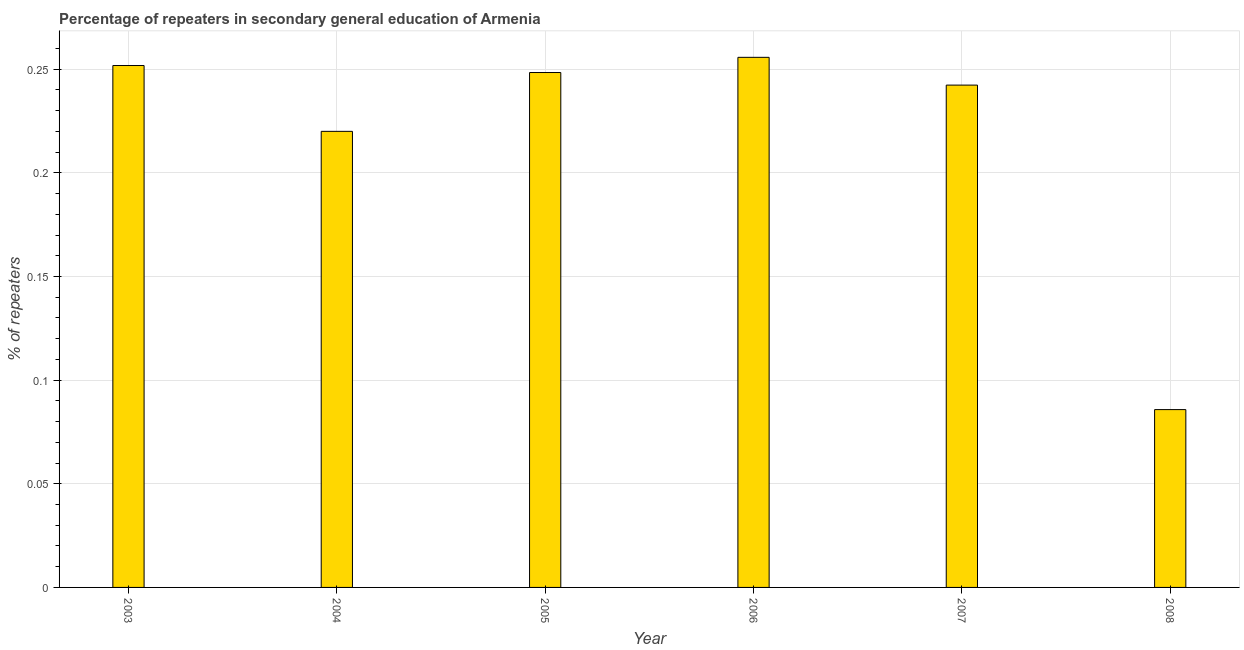Does the graph contain any zero values?
Give a very brief answer. No. Does the graph contain grids?
Ensure brevity in your answer.  Yes. What is the title of the graph?
Give a very brief answer. Percentage of repeaters in secondary general education of Armenia. What is the label or title of the Y-axis?
Offer a terse response. % of repeaters. What is the percentage of repeaters in 2005?
Your response must be concise. 0.25. Across all years, what is the maximum percentage of repeaters?
Keep it short and to the point. 0.26. Across all years, what is the minimum percentage of repeaters?
Provide a short and direct response. 0.09. In which year was the percentage of repeaters maximum?
Provide a succinct answer. 2006. What is the sum of the percentage of repeaters?
Provide a succinct answer. 1.3. What is the difference between the percentage of repeaters in 2005 and 2007?
Your response must be concise. 0.01. What is the average percentage of repeaters per year?
Make the answer very short. 0.22. What is the median percentage of repeaters?
Offer a very short reply. 0.25. What is the ratio of the percentage of repeaters in 2006 to that in 2007?
Give a very brief answer. 1.05. Is the percentage of repeaters in 2003 less than that in 2008?
Ensure brevity in your answer.  No. What is the difference between the highest and the second highest percentage of repeaters?
Offer a terse response. 0. What is the difference between the highest and the lowest percentage of repeaters?
Provide a short and direct response. 0.17. What is the difference between two consecutive major ticks on the Y-axis?
Offer a very short reply. 0.05. What is the % of repeaters of 2003?
Make the answer very short. 0.25. What is the % of repeaters of 2004?
Ensure brevity in your answer.  0.22. What is the % of repeaters of 2005?
Offer a very short reply. 0.25. What is the % of repeaters of 2006?
Your response must be concise. 0.26. What is the % of repeaters in 2007?
Offer a very short reply. 0.24. What is the % of repeaters of 2008?
Your answer should be compact. 0.09. What is the difference between the % of repeaters in 2003 and 2004?
Ensure brevity in your answer.  0.03. What is the difference between the % of repeaters in 2003 and 2005?
Ensure brevity in your answer.  0. What is the difference between the % of repeaters in 2003 and 2006?
Ensure brevity in your answer.  -0. What is the difference between the % of repeaters in 2003 and 2007?
Your answer should be very brief. 0.01. What is the difference between the % of repeaters in 2003 and 2008?
Ensure brevity in your answer.  0.17. What is the difference between the % of repeaters in 2004 and 2005?
Make the answer very short. -0.03. What is the difference between the % of repeaters in 2004 and 2006?
Make the answer very short. -0.04. What is the difference between the % of repeaters in 2004 and 2007?
Provide a succinct answer. -0.02. What is the difference between the % of repeaters in 2004 and 2008?
Your answer should be very brief. 0.13. What is the difference between the % of repeaters in 2005 and 2006?
Keep it short and to the point. -0.01. What is the difference between the % of repeaters in 2005 and 2007?
Your answer should be compact. 0.01. What is the difference between the % of repeaters in 2005 and 2008?
Your answer should be compact. 0.16. What is the difference between the % of repeaters in 2006 and 2007?
Keep it short and to the point. 0.01. What is the difference between the % of repeaters in 2006 and 2008?
Make the answer very short. 0.17. What is the difference between the % of repeaters in 2007 and 2008?
Offer a very short reply. 0.16. What is the ratio of the % of repeaters in 2003 to that in 2004?
Make the answer very short. 1.14. What is the ratio of the % of repeaters in 2003 to that in 2006?
Give a very brief answer. 0.98. What is the ratio of the % of repeaters in 2003 to that in 2007?
Provide a succinct answer. 1.04. What is the ratio of the % of repeaters in 2003 to that in 2008?
Your answer should be compact. 2.94. What is the ratio of the % of repeaters in 2004 to that in 2005?
Give a very brief answer. 0.89. What is the ratio of the % of repeaters in 2004 to that in 2006?
Give a very brief answer. 0.86. What is the ratio of the % of repeaters in 2004 to that in 2007?
Your answer should be very brief. 0.91. What is the ratio of the % of repeaters in 2004 to that in 2008?
Give a very brief answer. 2.56. What is the ratio of the % of repeaters in 2005 to that in 2007?
Your answer should be very brief. 1.02. What is the ratio of the % of repeaters in 2005 to that in 2008?
Keep it short and to the point. 2.9. What is the ratio of the % of repeaters in 2006 to that in 2007?
Provide a succinct answer. 1.05. What is the ratio of the % of repeaters in 2006 to that in 2008?
Make the answer very short. 2.98. What is the ratio of the % of repeaters in 2007 to that in 2008?
Give a very brief answer. 2.83. 